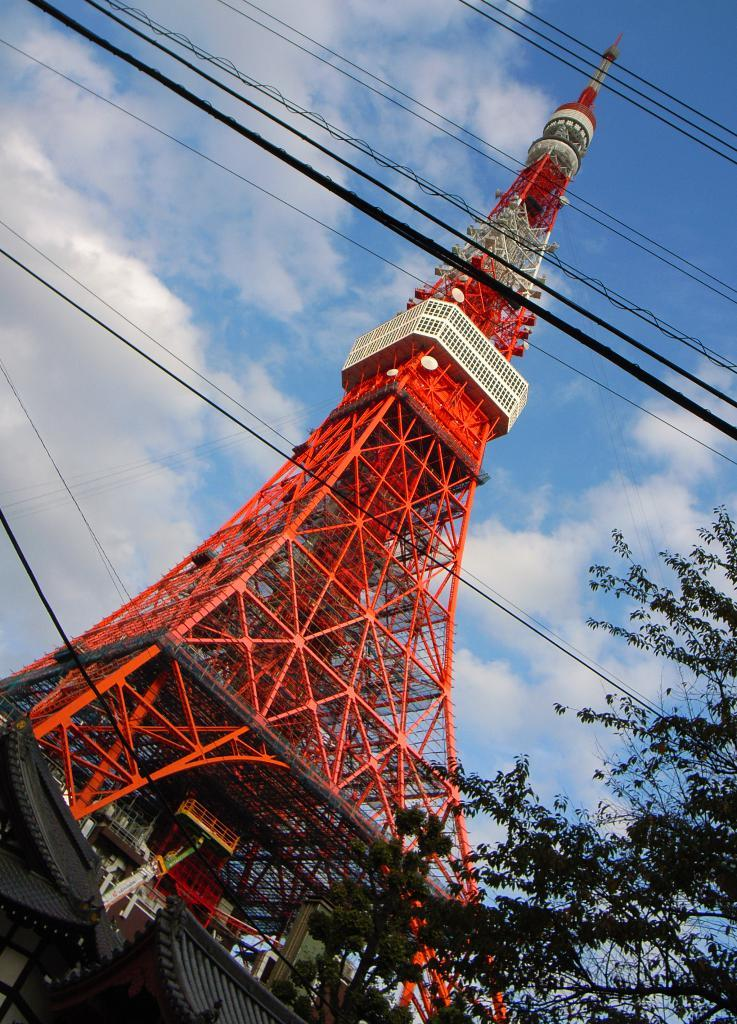What is the main structure in the center of the image? There is a tower in the center of the image. What type of buildings are located at the bottom of the image? There are sheds at the bottom of the image. What can be seen on the right side of the image? There is a tree on the right side of the image. What is visible at the top of the image? The sky is visible at the top of the image. What else can be seen at the top of the image? There are wires at the top of the image. What type of canvas is being used to paint the tower in the image? There is no canvas or painting activity present in the image; it is a photograph or illustration of the tower and other elements. 